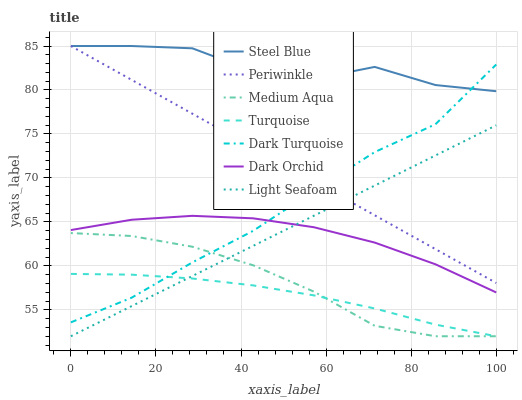Does Turquoise have the minimum area under the curve?
Answer yes or no. Yes. Does Steel Blue have the maximum area under the curve?
Answer yes or no. Yes. Does Dark Turquoise have the minimum area under the curve?
Answer yes or no. No. Does Dark Turquoise have the maximum area under the curve?
Answer yes or no. No. Is Periwinkle the smoothest?
Answer yes or no. Yes. Is Steel Blue the roughest?
Answer yes or no. Yes. Is Dark Turquoise the smoothest?
Answer yes or no. No. Is Dark Turquoise the roughest?
Answer yes or no. No. Does Turquoise have the lowest value?
Answer yes or no. Yes. Does Dark Turquoise have the lowest value?
Answer yes or no. No. Does Periwinkle have the highest value?
Answer yes or no. Yes. Does Dark Turquoise have the highest value?
Answer yes or no. No. Is Medium Aqua less than Steel Blue?
Answer yes or no. Yes. Is Steel Blue greater than Light Seafoam?
Answer yes or no. Yes. Does Periwinkle intersect Dark Turquoise?
Answer yes or no. Yes. Is Periwinkle less than Dark Turquoise?
Answer yes or no. No. Is Periwinkle greater than Dark Turquoise?
Answer yes or no. No. Does Medium Aqua intersect Steel Blue?
Answer yes or no. No. 